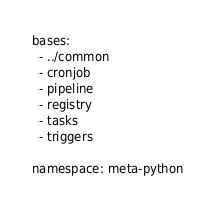<code> <loc_0><loc_0><loc_500><loc_500><_YAML_>bases:
  - ../common
  - cronjob
  - pipeline
  - registry
  - tasks
  - triggers

namespace: meta-python
</code> 